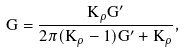<formula> <loc_0><loc_0><loc_500><loc_500>G = \frac { K _ { \rho } G ^ { \prime } } { 2 \pi ( K _ { \rho } - 1 ) G ^ { \prime } + K _ { \rho } } ,</formula> 